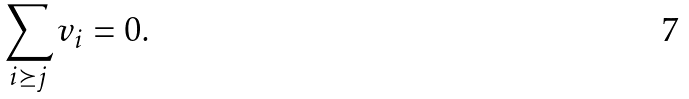Convert formula to latex. <formula><loc_0><loc_0><loc_500><loc_500>\sum _ { i \succeq j } v _ { i } = 0 .</formula> 